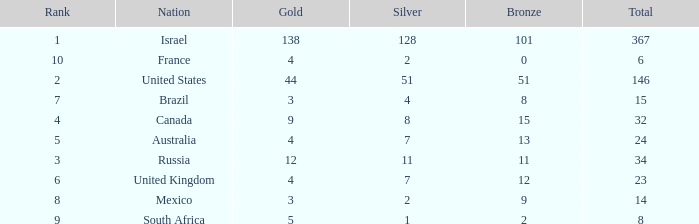What is the gold medal count for the country with a total greater than 32 and more than 128 silvers? None. 